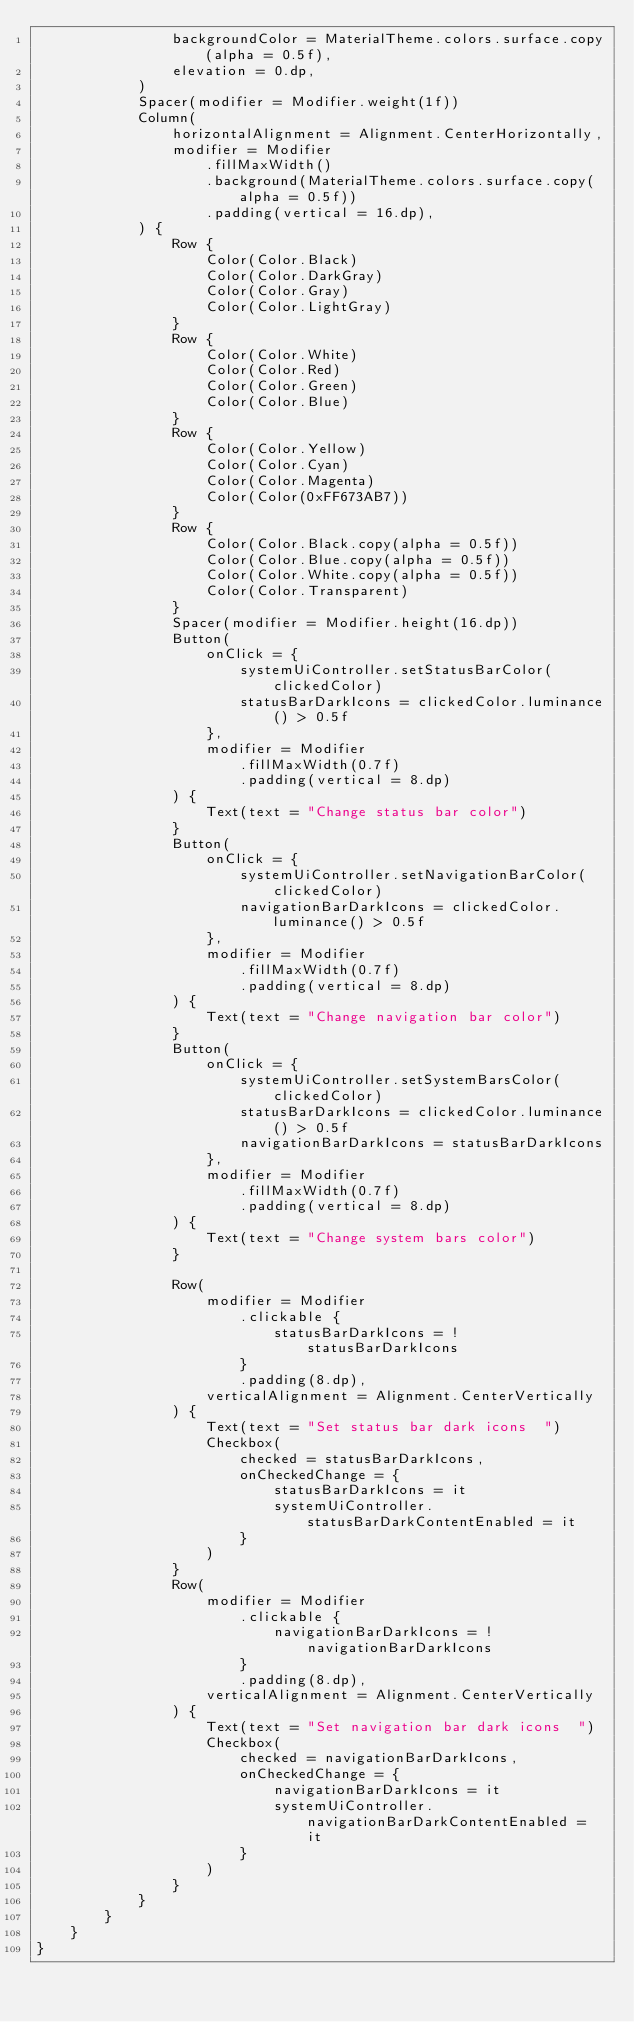Convert code to text. <code><loc_0><loc_0><loc_500><loc_500><_Kotlin_>                backgroundColor = MaterialTheme.colors.surface.copy(alpha = 0.5f),
                elevation = 0.dp,
            )
            Spacer(modifier = Modifier.weight(1f))
            Column(
                horizontalAlignment = Alignment.CenterHorizontally,
                modifier = Modifier
                    .fillMaxWidth()
                    .background(MaterialTheme.colors.surface.copy(alpha = 0.5f))
                    .padding(vertical = 16.dp),
            ) {
                Row {
                    Color(Color.Black)
                    Color(Color.DarkGray)
                    Color(Color.Gray)
                    Color(Color.LightGray)
                }
                Row {
                    Color(Color.White)
                    Color(Color.Red)
                    Color(Color.Green)
                    Color(Color.Blue)
                }
                Row {
                    Color(Color.Yellow)
                    Color(Color.Cyan)
                    Color(Color.Magenta)
                    Color(Color(0xFF673AB7))
                }
                Row {
                    Color(Color.Black.copy(alpha = 0.5f))
                    Color(Color.Blue.copy(alpha = 0.5f))
                    Color(Color.White.copy(alpha = 0.5f))
                    Color(Color.Transparent)
                }
                Spacer(modifier = Modifier.height(16.dp))
                Button(
                    onClick = {
                        systemUiController.setStatusBarColor(clickedColor)
                        statusBarDarkIcons = clickedColor.luminance() > 0.5f
                    },
                    modifier = Modifier
                        .fillMaxWidth(0.7f)
                        .padding(vertical = 8.dp)
                ) {
                    Text(text = "Change status bar color")
                }
                Button(
                    onClick = {
                        systemUiController.setNavigationBarColor(clickedColor)
                        navigationBarDarkIcons = clickedColor.luminance() > 0.5f
                    },
                    modifier = Modifier
                        .fillMaxWidth(0.7f)
                        .padding(vertical = 8.dp)
                ) {
                    Text(text = "Change navigation bar color")
                }
                Button(
                    onClick = {
                        systemUiController.setSystemBarsColor(clickedColor)
                        statusBarDarkIcons = clickedColor.luminance() > 0.5f
                        navigationBarDarkIcons = statusBarDarkIcons
                    },
                    modifier = Modifier
                        .fillMaxWidth(0.7f)
                        .padding(vertical = 8.dp)
                ) {
                    Text(text = "Change system bars color")
                }

                Row(
                    modifier = Modifier
                        .clickable {
                            statusBarDarkIcons = !statusBarDarkIcons
                        }
                        .padding(8.dp),
                    verticalAlignment = Alignment.CenterVertically
                ) {
                    Text(text = "Set status bar dark icons  ")
                    Checkbox(
                        checked = statusBarDarkIcons,
                        onCheckedChange = {
                            statusBarDarkIcons = it
                            systemUiController.statusBarDarkContentEnabled = it
                        }
                    )
                }
                Row(
                    modifier = Modifier
                        .clickable {
                            navigationBarDarkIcons = !navigationBarDarkIcons
                        }
                        .padding(8.dp),
                    verticalAlignment = Alignment.CenterVertically
                ) {
                    Text(text = "Set navigation bar dark icons  ")
                    Checkbox(
                        checked = navigationBarDarkIcons,
                        onCheckedChange = {
                            navigationBarDarkIcons = it
                            systemUiController.navigationBarDarkContentEnabled = it
                        }
                    )
                }
            }
        }
    }
}
</code> 